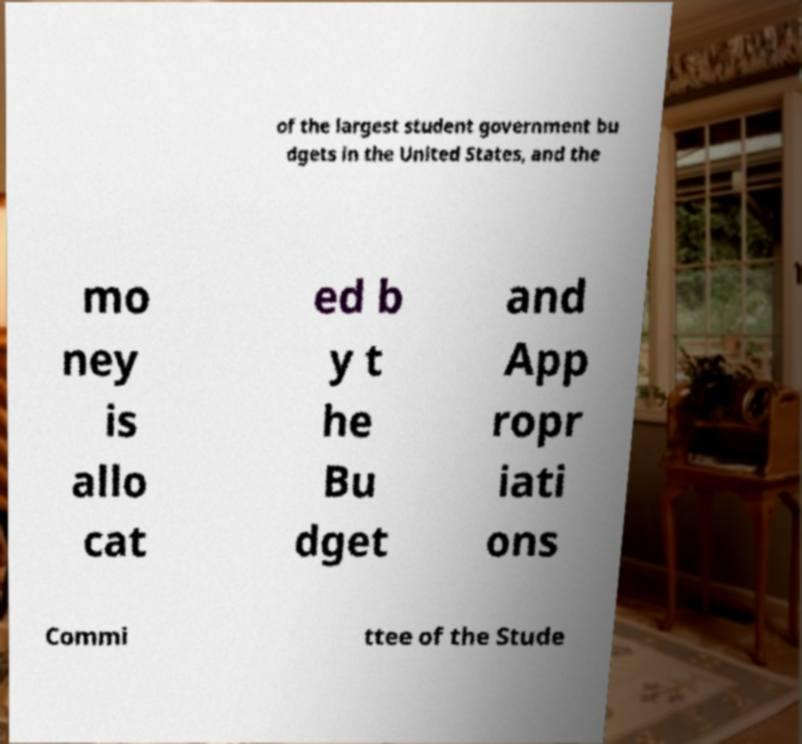What messages or text are displayed in this image? I need them in a readable, typed format. of the largest student government bu dgets in the United States, and the mo ney is allo cat ed b y t he Bu dget and App ropr iati ons Commi ttee of the Stude 